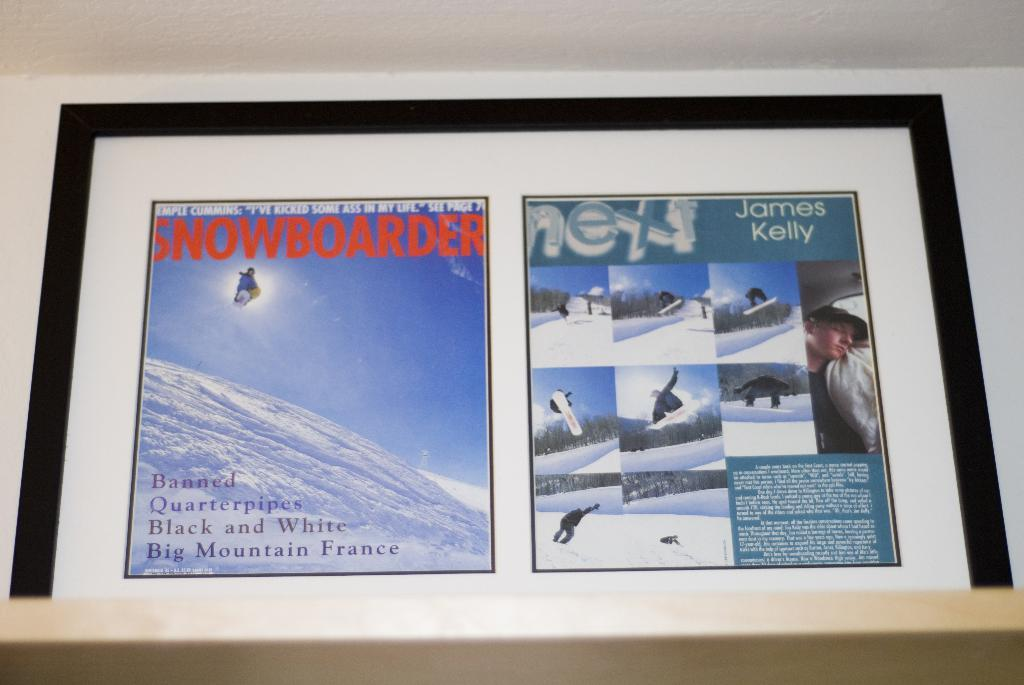<image>
Summarize the visual content of the image. A picture frame that has a Snowboarder article as well as pictures of snowboarders. 